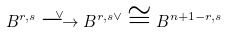<formula> <loc_0><loc_0><loc_500><loc_500>B ^ { r , s } \overset { \vee } { \longrightarrow } B ^ { r , s \vee } \cong B ^ { n + 1 - r , s }</formula> 